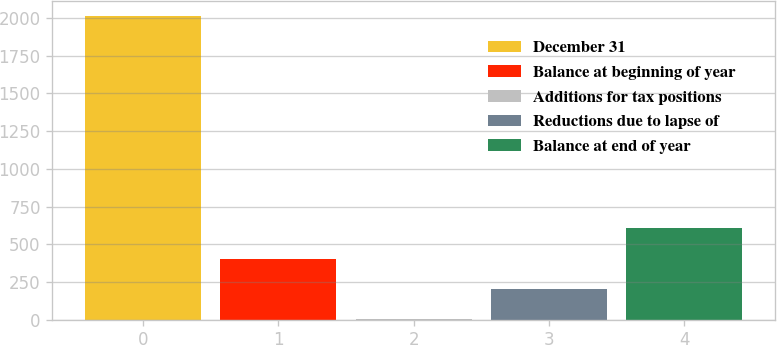<chart> <loc_0><loc_0><loc_500><loc_500><bar_chart><fcel>December 31<fcel>Balance at beginning of year<fcel>Additions for tax positions<fcel>Reductions due to lapse of<fcel>Balance at end of year<nl><fcel>2014<fcel>403.6<fcel>1<fcel>202.3<fcel>604.9<nl></chart> 